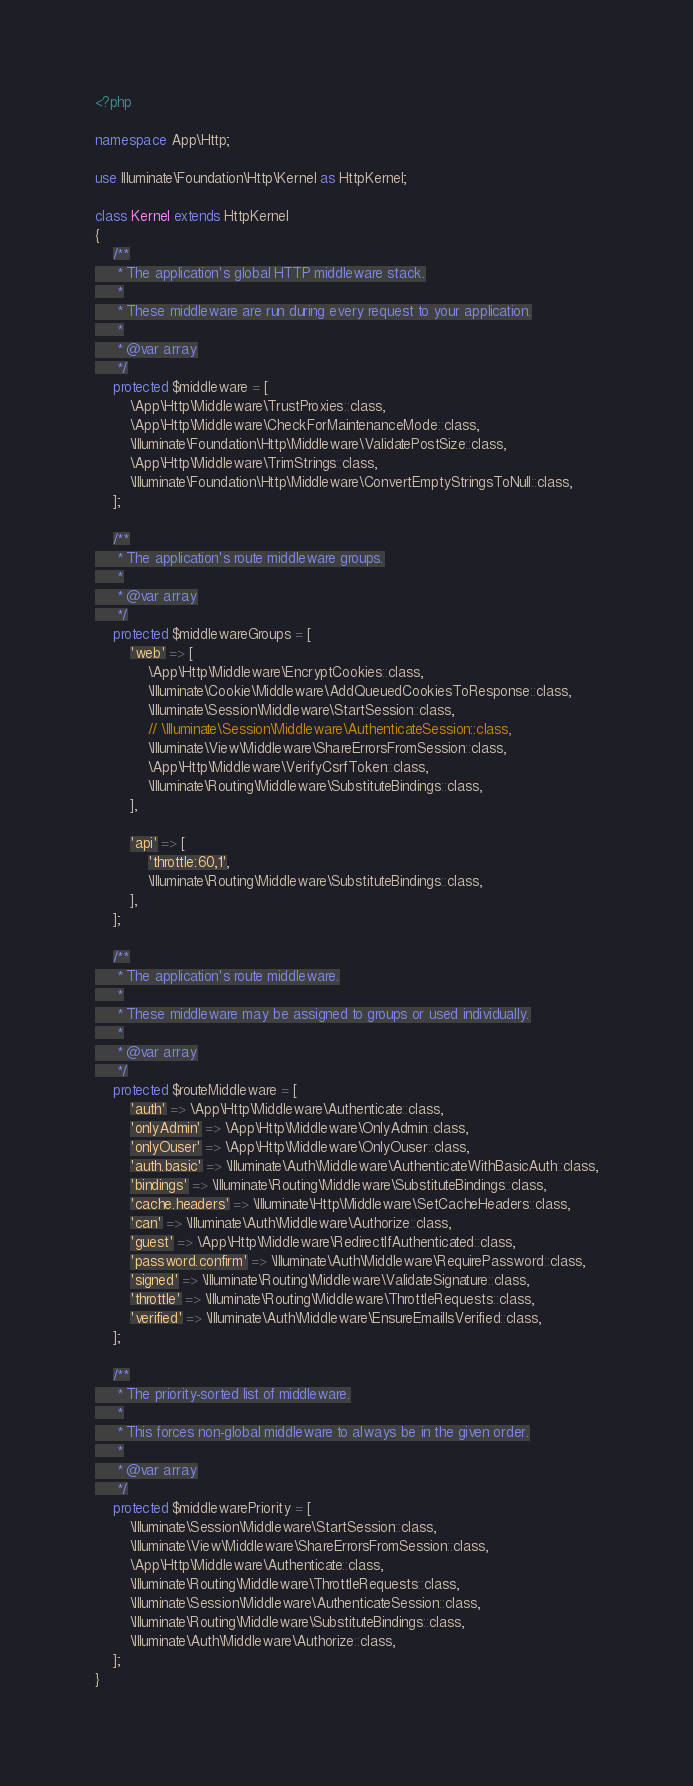Convert code to text. <code><loc_0><loc_0><loc_500><loc_500><_PHP_><?php

namespace App\Http;

use Illuminate\Foundation\Http\Kernel as HttpKernel;

class Kernel extends HttpKernel
{
    /**
     * The application's global HTTP middleware stack.
     *
     * These middleware are run during every request to your application.
     *
     * @var array
     */
    protected $middleware = [
        \App\Http\Middleware\TrustProxies::class,
        \App\Http\Middleware\CheckForMaintenanceMode::class,
        \Illuminate\Foundation\Http\Middleware\ValidatePostSize::class,
        \App\Http\Middleware\TrimStrings::class,
        \Illuminate\Foundation\Http\Middleware\ConvertEmptyStringsToNull::class,
    ];

    /**
     * The application's route middleware groups.
     *
     * @var array
     */
    protected $middlewareGroups = [
        'web' => [
            \App\Http\Middleware\EncryptCookies::class,
            \Illuminate\Cookie\Middleware\AddQueuedCookiesToResponse::class,
            \Illuminate\Session\Middleware\StartSession::class,
            // \Illuminate\Session\Middleware\AuthenticateSession::class,
            \Illuminate\View\Middleware\ShareErrorsFromSession::class,
            \App\Http\Middleware\VerifyCsrfToken::class,
            \Illuminate\Routing\Middleware\SubstituteBindings::class,
        ],

        'api' => [
            'throttle:60,1',
            \Illuminate\Routing\Middleware\SubstituteBindings::class,
        ],
    ];

    /**
     * The application's route middleware.
     *
     * These middleware may be assigned to groups or used individually.
     *
     * @var array
     */
    protected $routeMiddleware = [
        'auth' => \App\Http\Middleware\Authenticate::class,
        'onlyAdmin' => \App\Http\Middleware\OnlyAdmin::class,
        'onlyOuser' => \App\Http\Middleware\OnlyOuser::class,
        'auth.basic' => \Illuminate\Auth\Middleware\AuthenticateWithBasicAuth::class,
        'bindings' => \Illuminate\Routing\Middleware\SubstituteBindings::class,
        'cache.headers' => \Illuminate\Http\Middleware\SetCacheHeaders::class,
        'can' => \Illuminate\Auth\Middleware\Authorize::class,
        'guest' => \App\Http\Middleware\RedirectIfAuthenticated::class,
        'password.confirm' => \Illuminate\Auth\Middleware\RequirePassword::class,
        'signed' => \Illuminate\Routing\Middleware\ValidateSignature::class,
        'throttle' => \Illuminate\Routing\Middleware\ThrottleRequests::class,
        'verified' => \Illuminate\Auth\Middleware\EnsureEmailIsVerified::class,
    ];

    /**
     * The priority-sorted list of middleware.
     *
     * This forces non-global middleware to always be in the given order.
     *
     * @var array
     */
    protected $middlewarePriority = [
        \Illuminate\Session\Middleware\StartSession::class,
        \Illuminate\View\Middleware\ShareErrorsFromSession::class,
        \App\Http\Middleware\Authenticate::class,
        \Illuminate\Routing\Middleware\ThrottleRequests::class,
        \Illuminate\Session\Middleware\AuthenticateSession::class,
        \Illuminate\Routing\Middleware\SubstituteBindings::class,
        \Illuminate\Auth\Middleware\Authorize::class,
    ];
}
</code> 